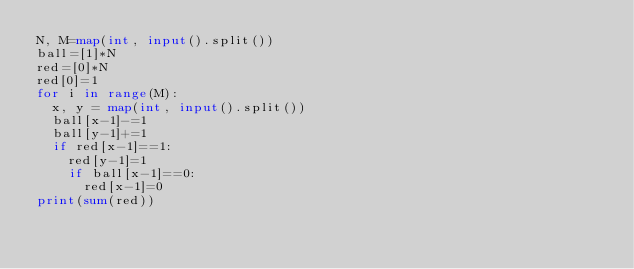<code> <loc_0><loc_0><loc_500><loc_500><_Python_>N, M=map(int, input().split())
ball=[1]*N
red=[0]*N
red[0]=1
for i in range(M):
  x, y = map(int, input().split())
  ball[x-1]-=1
  ball[y-1]+=1
  if red[x-1]==1:
    red[y-1]=1
    if ball[x-1]==0:
      red[x-1]=0
print(sum(red))</code> 